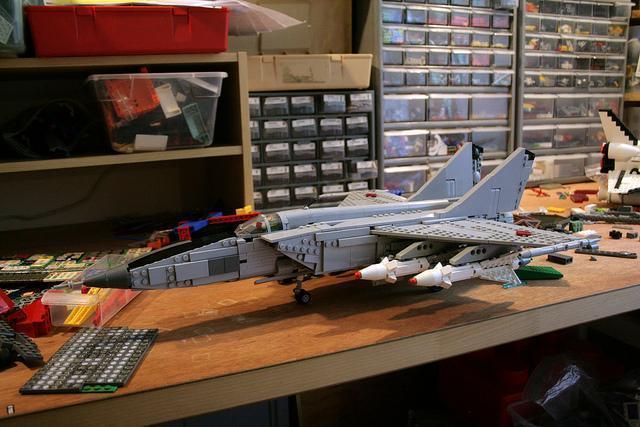What was used to build this plane?
Select the correct answer and articulate reasoning with the following format: 'Answer: answer
Rationale: rationale.'
Options: Metal, paper, plastic, legos. Answer: legos.
Rationale: The plane was built with lego pieces. 